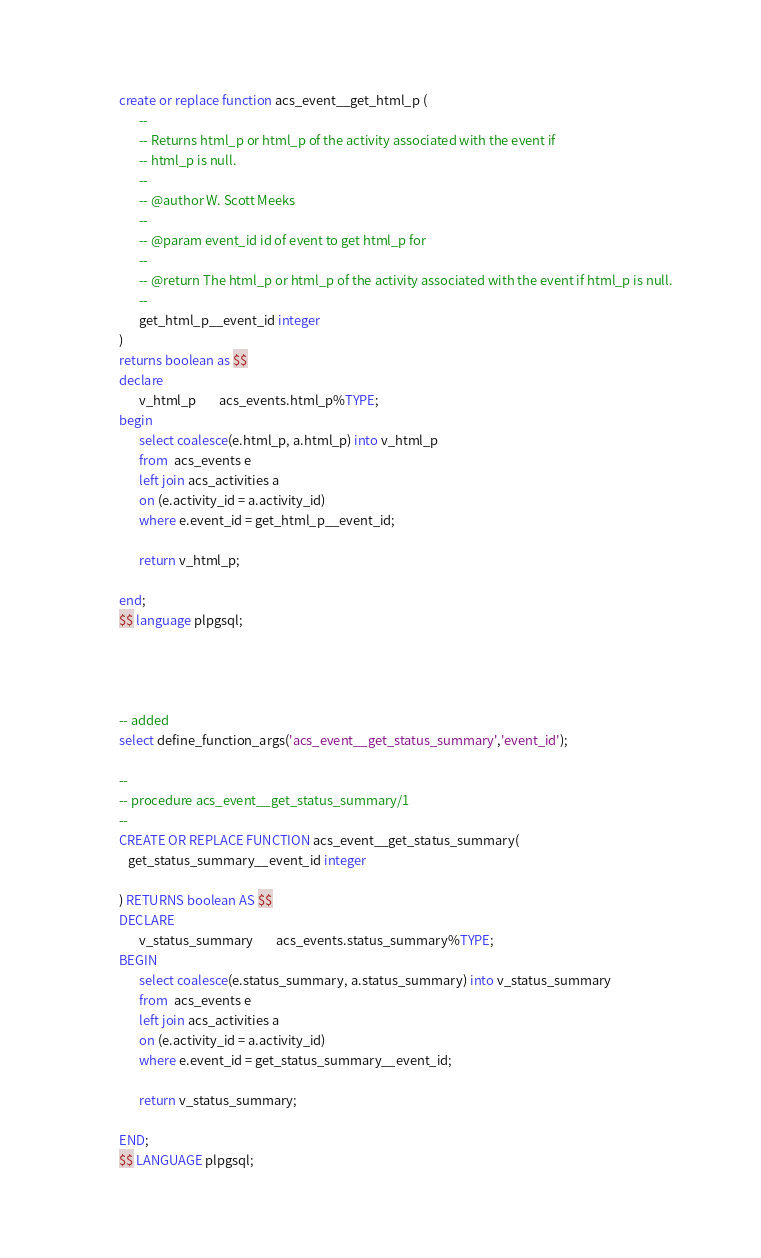<code> <loc_0><loc_0><loc_500><loc_500><_SQL_>create or replace function acs_event__get_html_p (
       --
       -- Returns html_p or html_p of the activity associated with the event if 
       -- html_p is null.
       --
       -- @author W. Scott Meeks
       --
       -- @param event_id id of event to get html_p for
       --
       -- @return The html_p or html_p of the activity associated with the event if html_p is null.
       --
       get_html_p__event_id integer
)
returns boolean as $$
declare
       v_html_p		acs_events.html_p%TYPE; 
begin
       select coalesce(e.html_p, a.html_p) into v_html_p
       from  acs_events e
       left join acs_activities a
       on (e.activity_id = a.activity_id)
       where e.event_id = get_html_p__event_id;

       return v_html_p;

end;
$$ language plpgsql;




-- added
select define_function_args('acs_event__get_status_summary','event_id');

--
-- procedure acs_event__get_status_summary/1
--
CREATE OR REPLACE FUNCTION acs_event__get_status_summary(
   get_status_summary__event_id integer

) RETURNS boolean AS $$
DECLARE
       v_status_summary		acs_events.status_summary%TYPE; 
BEGIN
       select coalesce(e.status_summary, a.status_summary) into v_status_summary
       from  acs_events e
       left join acs_activities a
       on (e.activity_id = a.activity_id)
       where e.event_id = get_status_summary__event_id;

       return v_status_summary;

END;
$$ LANGUAGE plpgsql;

</code> 